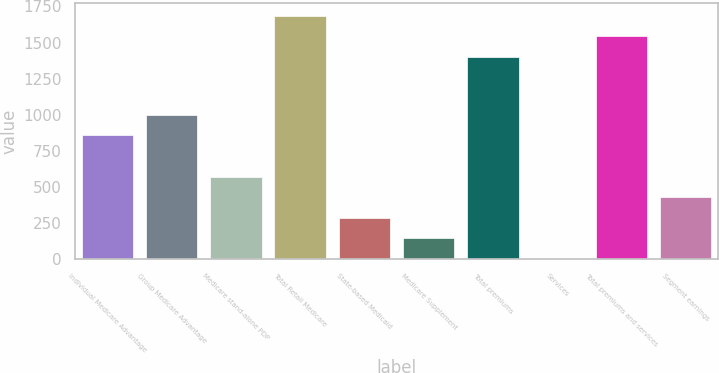Convert chart to OTSL. <chart><loc_0><loc_0><loc_500><loc_500><bar_chart><fcel>Individual Medicare Advantage<fcel>Group Medicare Advantage<fcel>Medicare stand-alone PDP<fcel>Total Retail Medicare<fcel>State-based Medicaid<fcel>Medicare Supplement<fcel>Total premiums<fcel>Services<fcel>Total premiums and services<fcel>Segment earnings<nl><fcel>857<fcel>998.8<fcel>571.2<fcel>1686.6<fcel>287.6<fcel>145.8<fcel>1403<fcel>4<fcel>1544.8<fcel>429.4<nl></chart> 